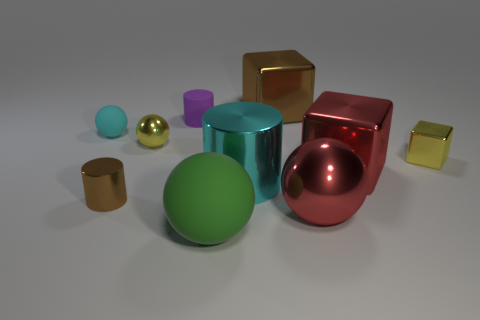What number of brown things are on the right side of the small cylinder that is in front of the tiny thing to the right of the green object?
Provide a succinct answer. 1. There is a cyan object left of the tiny metallic cylinder; is it the same shape as the purple thing?
Keep it short and to the point. No. There is a big ball that is to the right of the big metallic cylinder; are there any tiny purple rubber cylinders in front of it?
Keep it short and to the point. No. What number of tiny yellow metal blocks are there?
Provide a short and direct response. 1. What color is the tiny metallic thing that is to the left of the big brown shiny cube and behind the tiny brown thing?
Ensure brevity in your answer.  Yellow. There is a yellow thing that is the same shape as the cyan matte thing; what size is it?
Your answer should be very brief. Small. How many purple metallic cylinders have the same size as the yellow metal cube?
Your answer should be compact. 0. What is the tiny brown cylinder made of?
Your response must be concise. Metal. There is a big cyan cylinder; are there any tiny metal blocks on the left side of it?
Make the answer very short. No. There is a sphere that is made of the same material as the green thing; what is its size?
Make the answer very short. Small. 